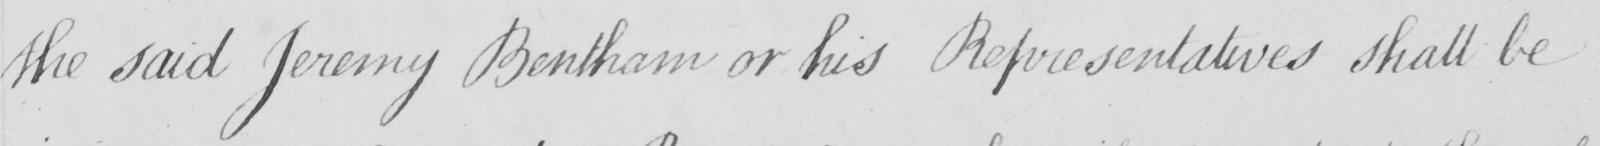Can you tell me what this handwritten text says? the said Jeremy Bentham or his Representatives shall be 